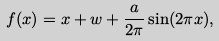<formula> <loc_0><loc_0><loc_500><loc_500>f ( x ) = x + w + \frac { a } { 2 \pi } \sin ( 2 \pi x ) ,</formula> 